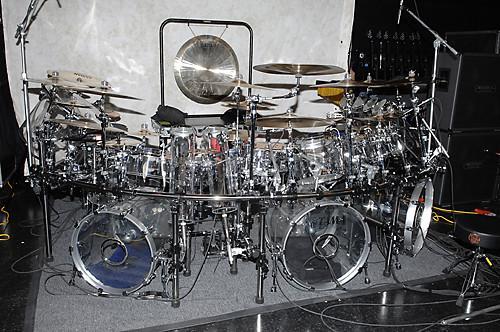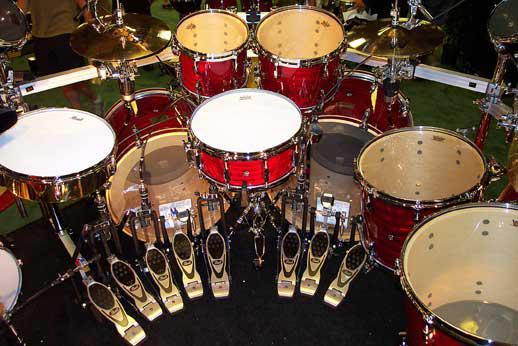The first image is the image on the left, the second image is the image on the right. For the images shown, is this caption "One of the images is taken from behind a single drum kit." true? Answer yes or no. Yes. The first image is the image on the left, the second image is the image on the right. Given the left and right images, does the statement "There are three standing drums with at least two of them facing forward left." hold true? Answer yes or no. No. 